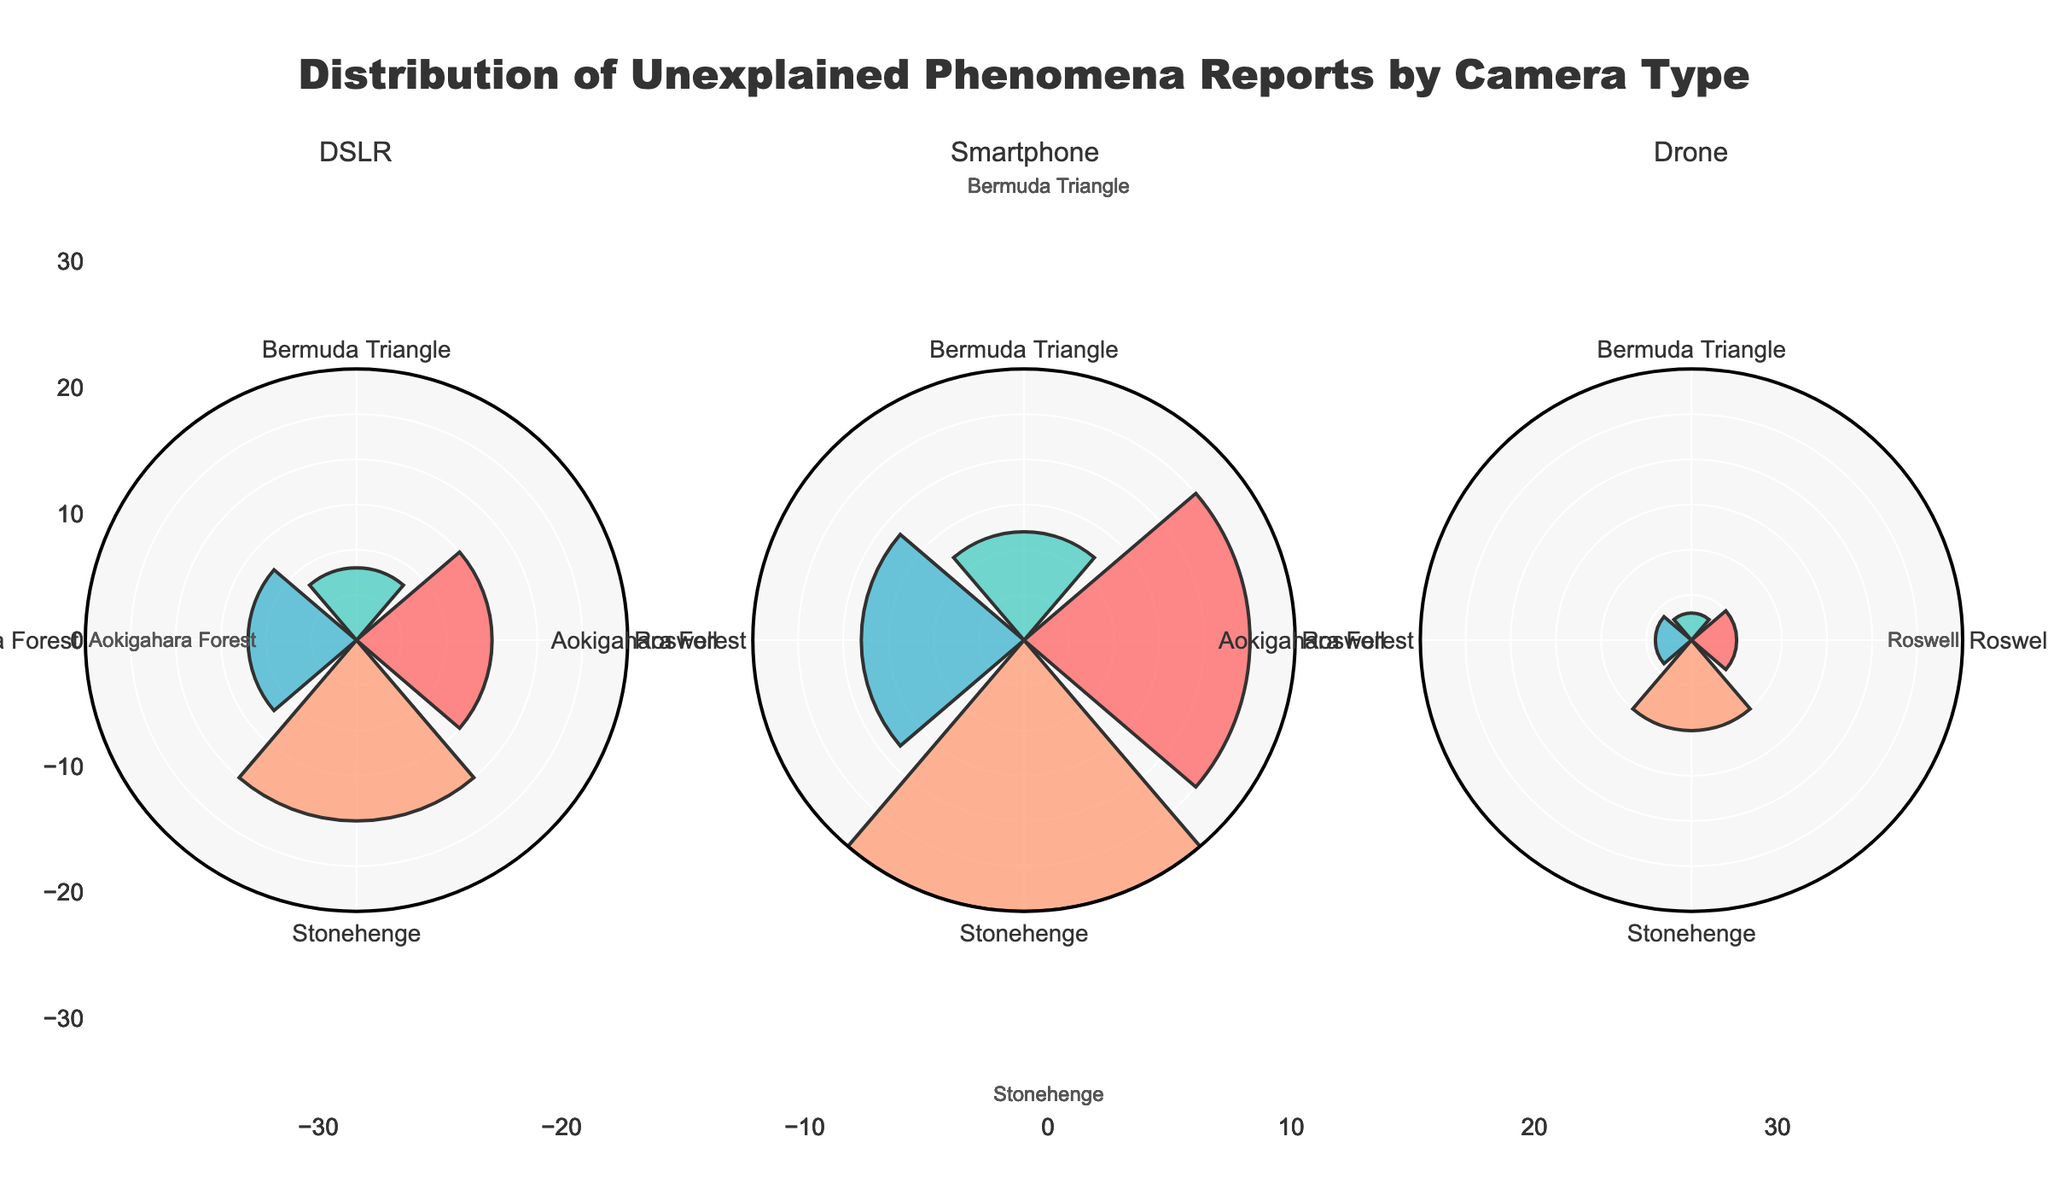What's the title of the figure? The title is displayed at the top center of the figure with a larger and bold font. It reads "Distribution of Unexplained Phenomena Reports by Camera Type."
Answer: Distribution of Unexplained Phenomena Reports by Camera Type How many unexplained phenomena reports were captured with a drone at Stonehenge? In the subplot for drones, the petal corresponding to Stonehenge extends to a radial value indicating the number of reports, which is 10.
Answer: 10 Which camera type reported the highest number of unexplained phenomena at Roswell? Compare the radial lengths of the petals for Roswell across all three camera types. The smartphone's petal is the longest, indicating it captured the highest number of reports with 25.
Answer: Smartphone What is the total number of reports captured using a DSLR? Sum the number of reports for a DSLR across all locations: 15 (Roswell) + 8 (Bermuda Triangle) + 12 (Aokigahara Forest) + 20 (Stonehenge) = 55.
Answer: 55 Which location has the least number of unexplained phenomena reports captured with a smartphone? Look at the radial length of the petals in the smartphone subplot. The Bermuda Triangle petal is the shortest, indicating the lowest number with 12 reports.
Answer: Bermuda Triangle What is the combined number of reports from drones at Bermuda Triangle and Aokigahara Forest? Add the number of reports from these locations: 3 (Bermuda Triangle) + 4 (Aokigahara Forest) = 7.
Answer: 7 Which camera type has the most balanced distribution of reports across all locations? Visually compare the subplots. The drone's subplot shows the most uniform radial lengths across locations, suggesting a more balanced distribution.
Answer: Drone What is the difference in the number of reports between DSLR and smartphone at Stonehenge? Subtract the number of reports for DSLR (20) from those for smartphone (30): 30 - 20 = 10.
Answer: 10 How does the number of smartphone reports at Aokigahara Forest compare to those at Stonehenge? Compare the radial lengths for smartphone reports in these two locations. Stonehenge has 30 reports while Aokigahara Forest has 18. Stonehenge has 12 more reports than Aokigahara Forest.
Answer: Stonehenge has 12 more Are there more reports captured with a drone or a DSLR at the Bermuda Triangle during winter? Compare the radial lengths in the drone and DSLR subplots for the Bermuda Triangle. DSLR has 8 reports while drone has 3. DSLR has more reports.
Answer: DSLR 